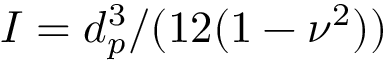Convert formula to latex. <formula><loc_0><loc_0><loc_500><loc_500>I = d _ { p } ^ { 3 } / ( 1 2 ( 1 - \nu ^ { 2 } ) )</formula> 